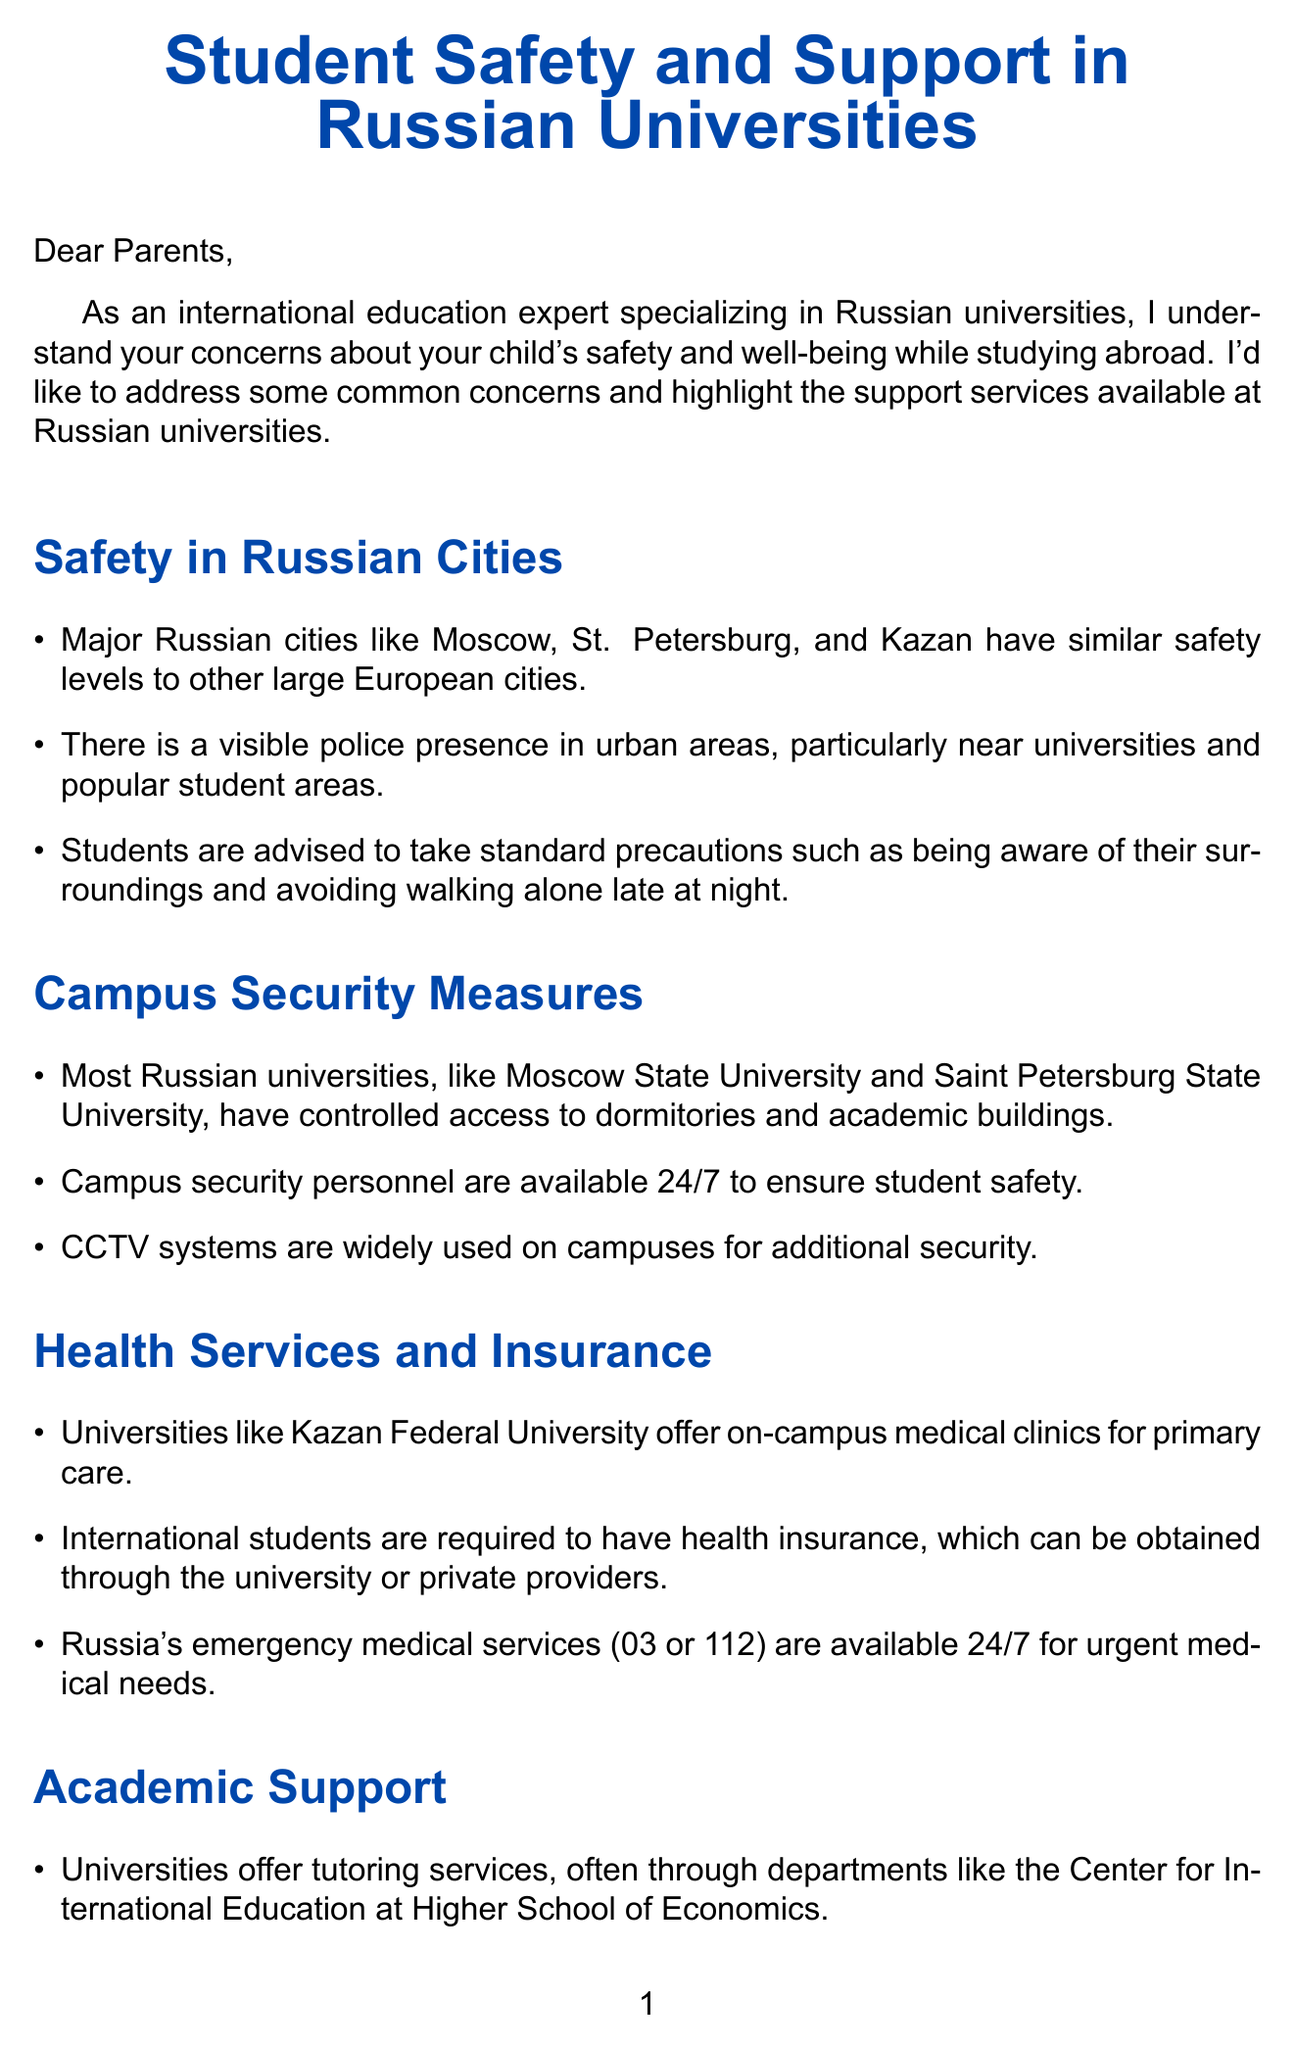What is the title of the document? The title is presented at the beginning of the document, stating the focus on student safety and support.
Answer: Student Safety and Support in Russian Universities What major Russian cities are mentioned regarding safety? The document explicitly lists cities providing context on safety levels like other European cities.
Answer: Moscow, St. Petersburg, and Kazan How many hours a day are campus security personnel available? The document states that campus security is available around the clock, indicating they work ceaselessly.
Answer: 24/7 What is required for international students' health insurance? The letter specifies that international students must acquire health insurance for their stay.
Answer: Required What type of academic support is mentioned for language help? The document specifically states the availability of language assistance services at specific universities.
Answer: Preparatory Faculty What service do universities maintain for emergencies? The text mentions a specific type of hotline that universities provide for students in crisis situations.
Answer: 24/7 emergency hotlines Which organization helps with cultural adaptation? The document refers to a specific network that assists international students.
Answer: ESN (Erasmus Student Network) What type of events are organized to understand Russian culture? Regular activities are highlighted for students in relation to cultural integration in the document.
Answer: Cultural events and excursions What additional resources link is provided for studying in Russia? The document lists official sources where students can find more information.
Answer: https://studyinrussia.ru/en/ 